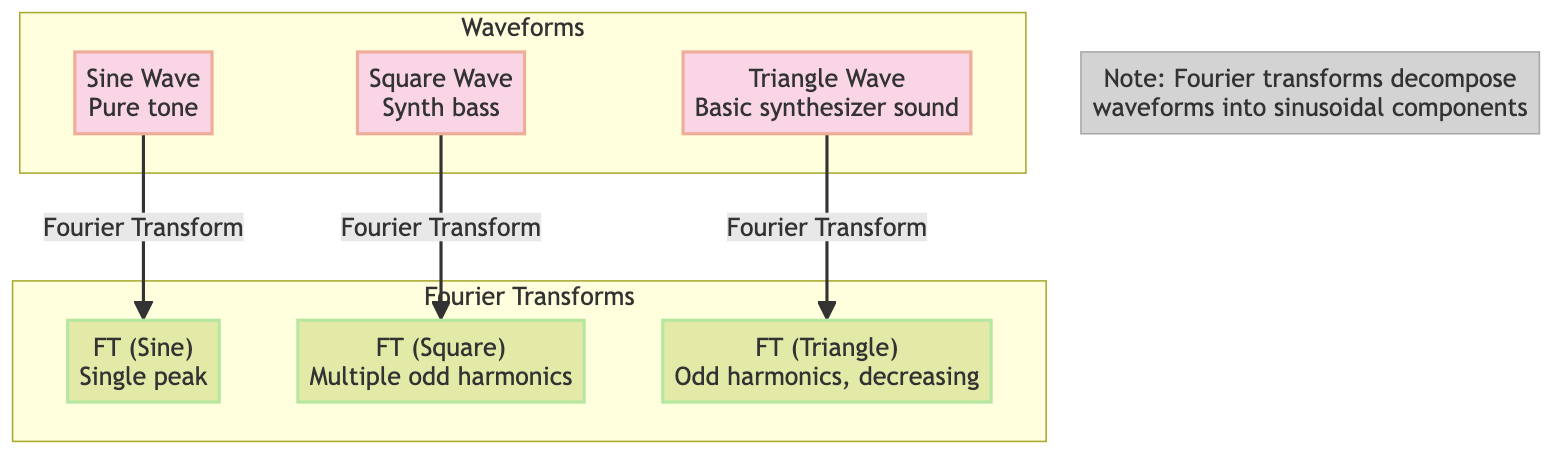What types of waveforms are shown in the diagram? The diagram shows three types of waveforms labeled as Sine Wave, Square Wave, and Triangle Wave, which can be found in the "Waveforms" subgraph.
Answer: Sine Wave, Square Wave, Triangle Wave How many Fourier Transform nodes are present in the diagram? There are three Fourier Transform nodes corresponding to the three waveforms, identified in the "Fourier Transforms" subgraph.
Answer: Three What harmonic content does the Square Wave Fourier Transform feature? The Square Wave Fourier Transform shows "Multiple odd harmonics," a key detail labeled next to its node in the diagram.
Answer: Multiple odd harmonics What does the Sine Wave Fourier Transform indicate in terms of peaks? The Fourier Transform of the Sine Wave indicates "Single peak," which is explicitly mentioned next to the sine_ft node in the diagram.
Answer: Single peak Which waveform corresponds to the label "Basic synthesizer sound"? The label "Basic synthesizer sound" is associated with the Triangle Wave node, as noted above the Triangle Wave in the diagram.
Answer: Triangle Wave What is the main distinction in harmonic content between the Triangle Wave and its Fourier Transform? The Triangle Wave's Fourier Transform is characterized by "Odd harmonics, decreasing," indicating a clear distinction in the harmonic content described in the diagram.
Answer: Odd harmonics, decreasing What is the relationship between the Square Wave and its Fourier Transform? The relationship shown in the diagram is that the Square Wave undergoes a process called Fourier Transform, resulting in its Fourier Transform labeled with multiple odd harmonics.
Answer: Fourier Transform What does the note in the diagram explain about Fourier transforms? The note clarifies that Fourier transforms decompose waveforms into their sinusoidal components, giving additional context to the transformation process depicted in the diagram.
Answer: Decompose waveforms into sinusoidal components 